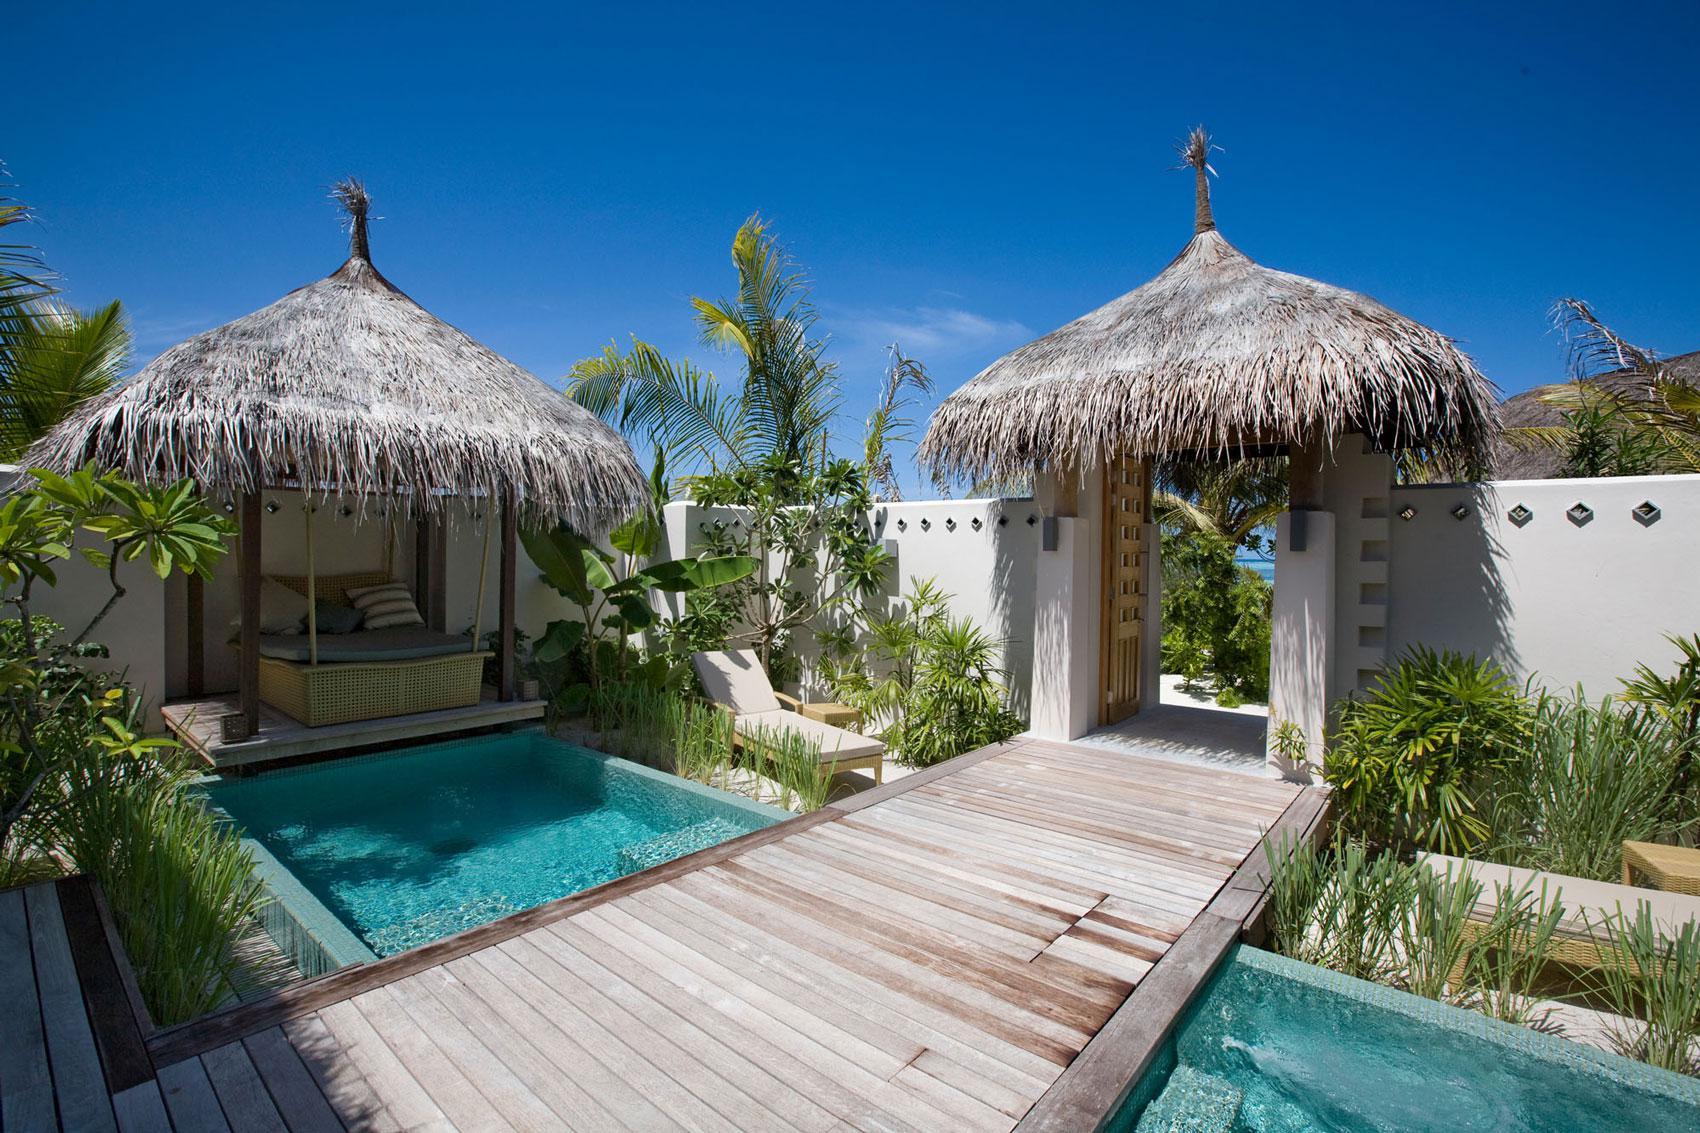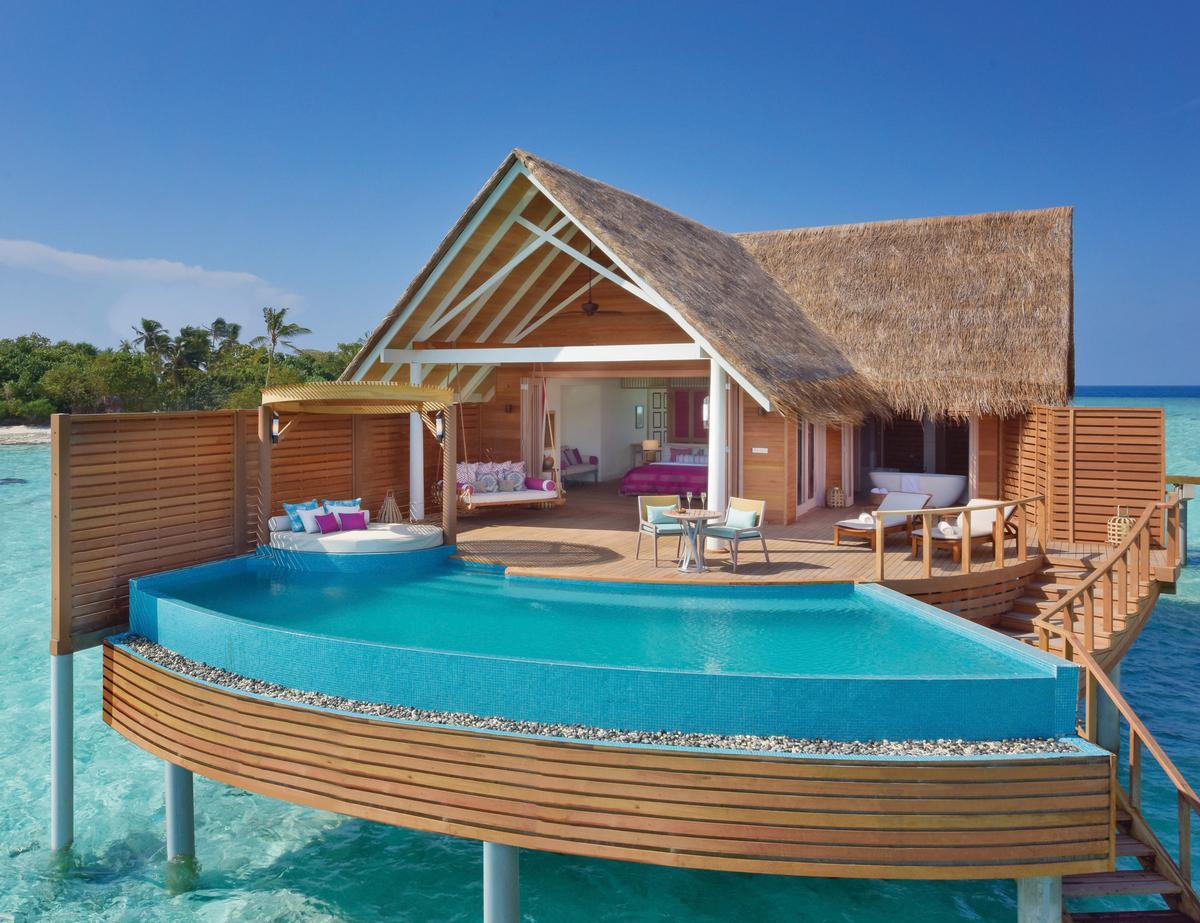The first image is the image on the left, the second image is the image on the right. Examine the images to the left and right. Is the description "A pier crosses the water in the image on the left." accurate? Answer yes or no. Yes. The first image is the image on the left, the second image is the image on the right. For the images displayed, is the sentence "Left and right images feature thatch-roofed buildings on a beach, and the right image includes a curving swimming pool." factually correct? Answer yes or no. Yes. 